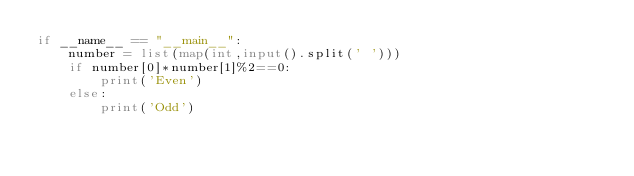Convert code to text. <code><loc_0><loc_0><loc_500><loc_500><_Python_>if __name__ == "__main__":
    number = list(map(int,input().split(' ')))
    if number[0]*number[1]%2==0:
        print('Even')
    else:
        print('Odd')</code> 